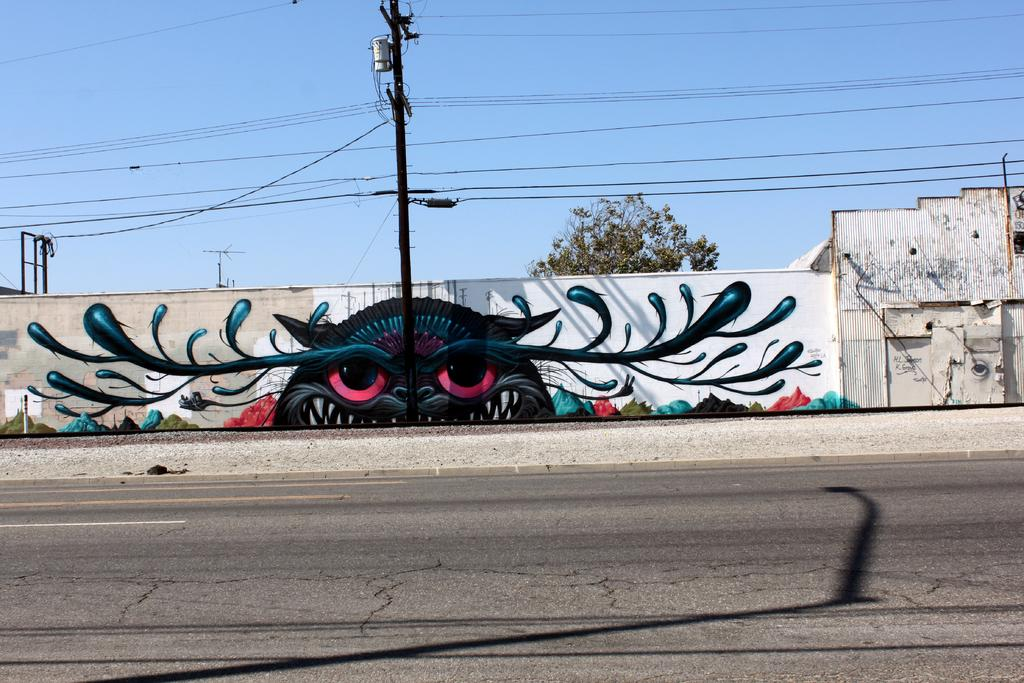What is the main object in the center of the image? There is a current pole in the center of the image. What is located at the bottom of the image? There is a road at the bottom of the image. What can be seen in the background of the image? There is a wall, a building, wires, a tree, and the sky visible in the background of the image. What type of popcorn is being served at the event in the image? There is no event or popcorn present in the image; it features a current pole, a road, and various background elements. 